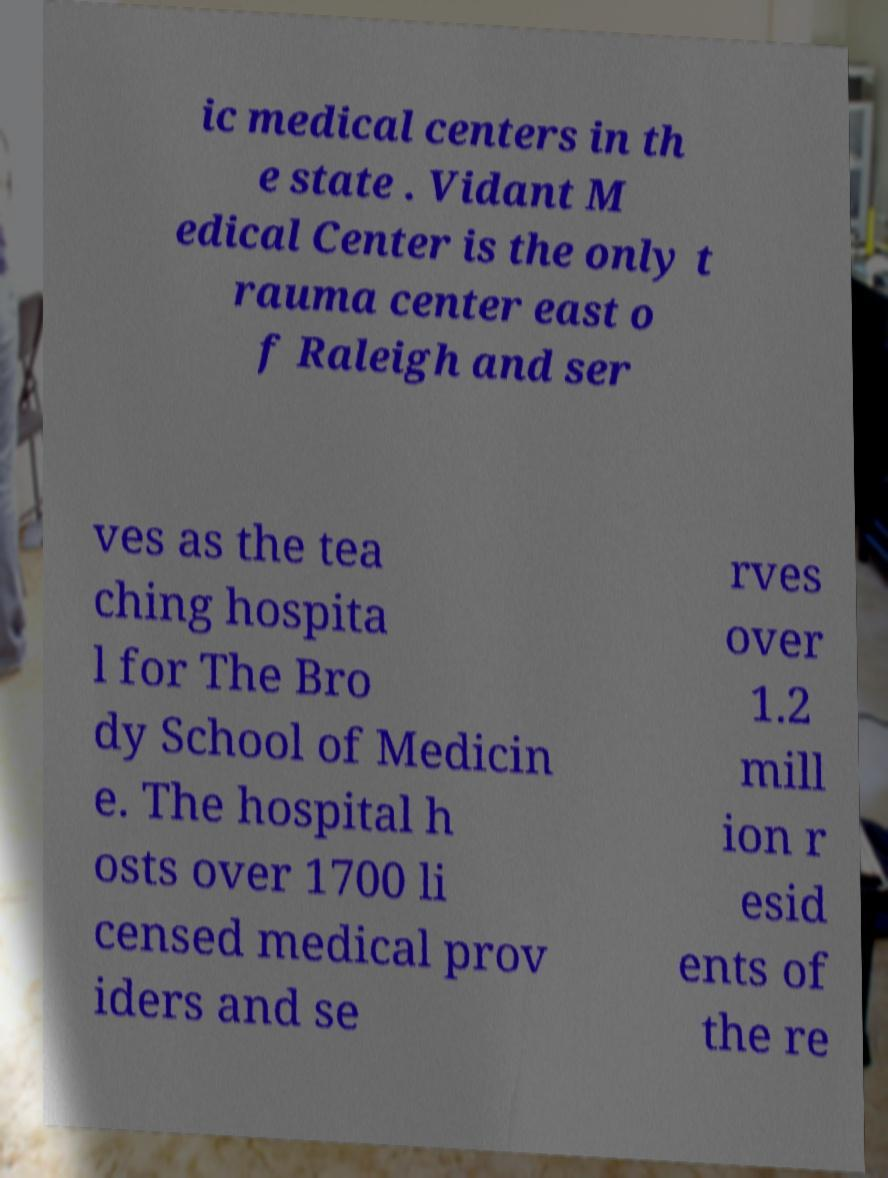Could you extract and type out the text from this image? ic medical centers in th e state . Vidant M edical Center is the only t rauma center east o f Raleigh and ser ves as the tea ching hospita l for The Bro dy School of Medicin e. The hospital h osts over 1700 li censed medical prov iders and se rves over 1.2 mill ion r esid ents of the re 